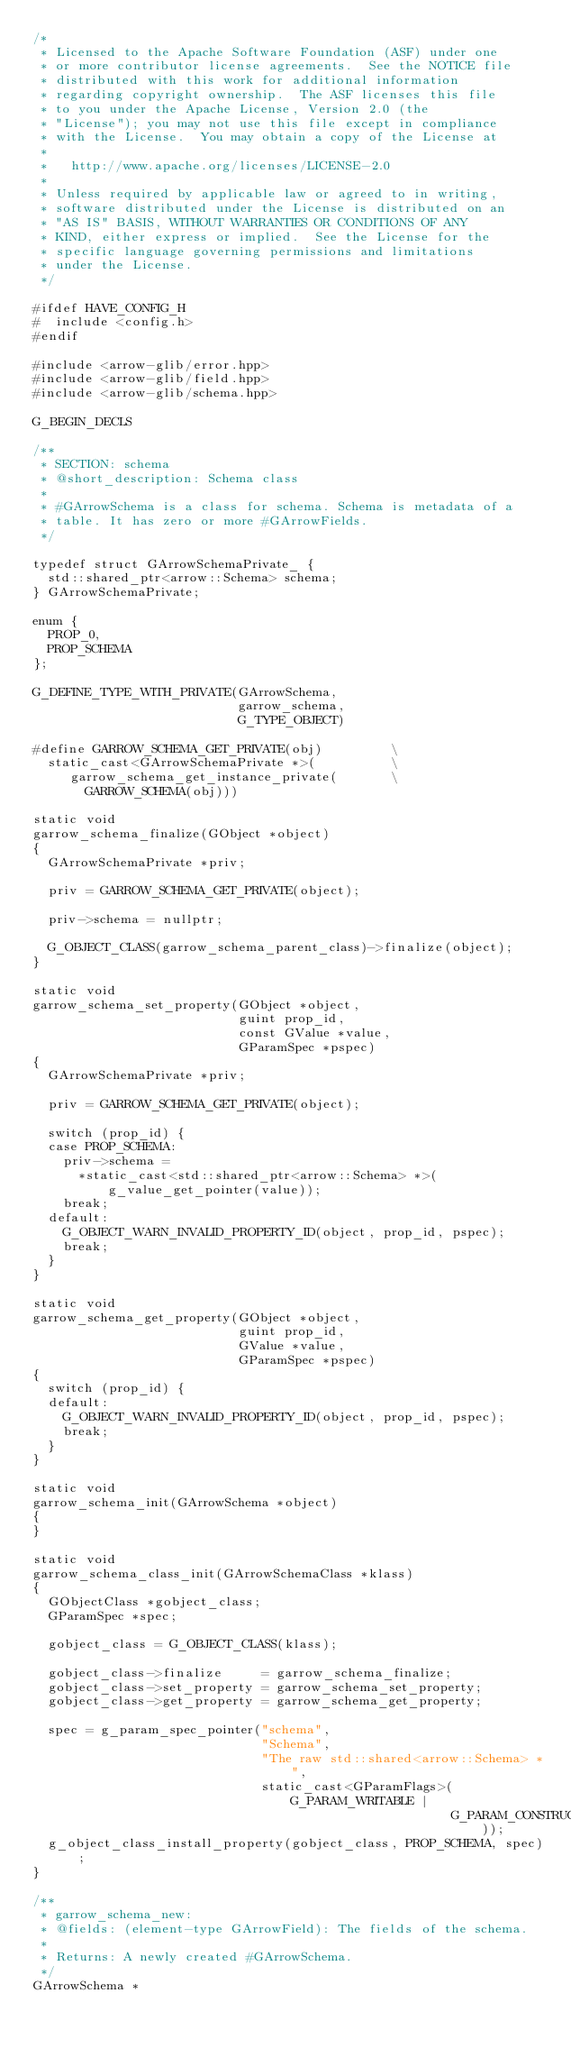Convert code to text. <code><loc_0><loc_0><loc_500><loc_500><_C++_>/*
 * Licensed to the Apache Software Foundation (ASF) under one
 * or more contributor license agreements.  See the NOTICE file
 * distributed with this work for additional information
 * regarding copyright ownership.  The ASF licenses this file
 * to you under the Apache License, Version 2.0 (the
 * "License"); you may not use this file except in compliance
 * with the License.  You may obtain a copy of the License at
 *
 *   http://www.apache.org/licenses/LICENSE-2.0
 *
 * Unless required by applicable law or agreed to in writing,
 * software distributed under the License is distributed on an
 * "AS IS" BASIS, WITHOUT WARRANTIES OR CONDITIONS OF ANY
 * KIND, either express or implied.  See the License for the
 * specific language governing permissions and limitations
 * under the License.
 */

#ifdef HAVE_CONFIG_H
#  include <config.h>
#endif

#include <arrow-glib/error.hpp>
#include <arrow-glib/field.hpp>
#include <arrow-glib/schema.hpp>

G_BEGIN_DECLS

/**
 * SECTION: schema
 * @short_description: Schema class
 *
 * #GArrowSchema is a class for schema. Schema is metadata of a
 * table. It has zero or more #GArrowFields.
 */

typedef struct GArrowSchemaPrivate_ {
  std::shared_ptr<arrow::Schema> schema;
} GArrowSchemaPrivate;

enum {
  PROP_0,
  PROP_SCHEMA
};

G_DEFINE_TYPE_WITH_PRIVATE(GArrowSchema,
                           garrow_schema,
                           G_TYPE_OBJECT)

#define GARROW_SCHEMA_GET_PRIVATE(obj)         \
  static_cast<GArrowSchemaPrivate *>(          \
     garrow_schema_get_instance_private(       \
       GARROW_SCHEMA(obj)))

static void
garrow_schema_finalize(GObject *object)
{
  GArrowSchemaPrivate *priv;

  priv = GARROW_SCHEMA_GET_PRIVATE(object);

  priv->schema = nullptr;

  G_OBJECT_CLASS(garrow_schema_parent_class)->finalize(object);
}

static void
garrow_schema_set_property(GObject *object,
                           guint prop_id,
                           const GValue *value,
                           GParamSpec *pspec)
{
  GArrowSchemaPrivate *priv;

  priv = GARROW_SCHEMA_GET_PRIVATE(object);

  switch (prop_id) {
  case PROP_SCHEMA:
    priv->schema =
      *static_cast<std::shared_ptr<arrow::Schema> *>(g_value_get_pointer(value));
    break;
  default:
    G_OBJECT_WARN_INVALID_PROPERTY_ID(object, prop_id, pspec);
    break;
  }
}

static void
garrow_schema_get_property(GObject *object,
                           guint prop_id,
                           GValue *value,
                           GParamSpec *pspec)
{
  switch (prop_id) {
  default:
    G_OBJECT_WARN_INVALID_PROPERTY_ID(object, prop_id, pspec);
    break;
  }
}

static void
garrow_schema_init(GArrowSchema *object)
{
}

static void
garrow_schema_class_init(GArrowSchemaClass *klass)
{
  GObjectClass *gobject_class;
  GParamSpec *spec;

  gobject_class = G_OBJECT_CLASS(klass);

  gobject_class->finalize     = garrow_schema_finalize;
  gobject_class->set_property = garrow_schema_set_property;
  gobject_class->get_property = garrow_schema_get_property;

  spec = g_param_spec_pointer("schema",
                              "Schema",
                              "The raw std::shared<arrow::Schema> *",
                              static_cast<GParamFlags>(G_PARAM_WRITABLE |
                                                       G_PARAM_CONSTRUCT_ONLY));
  g_object_class_install_property(gobject_class, PROP_SCHEMA, spec);
}

/**
 * garrow_schema_new:
 * @fields: (element-type GArrowField): The fields of the schema.
 *
 * Returns: A newly created #GArrowSchema.
 */
GArrowSchema *</code> 